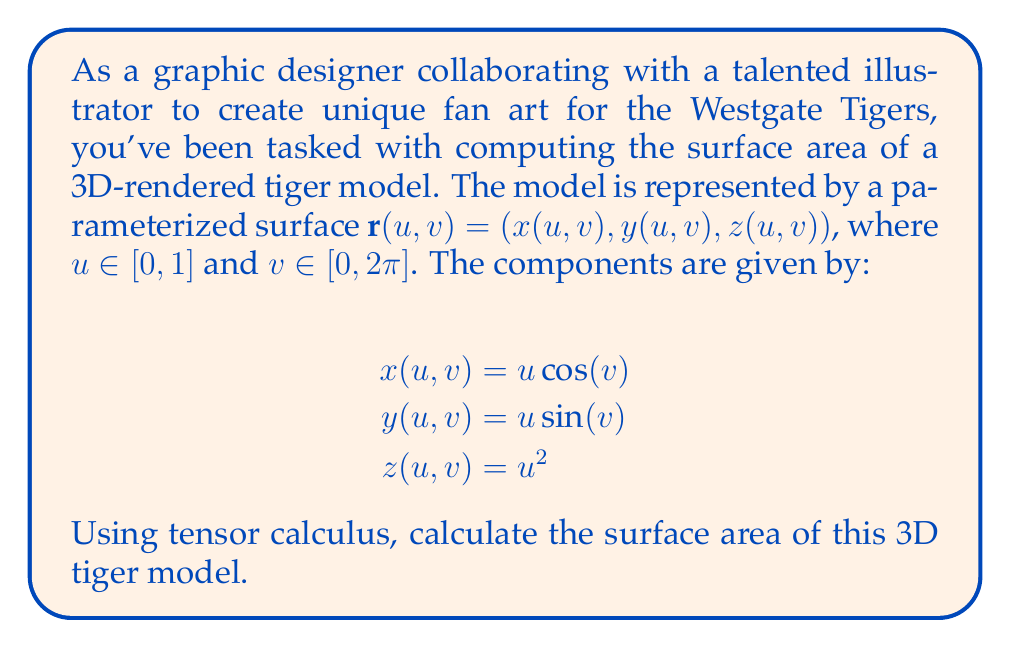What is the answer to this math problem? To compute the surface area using tensor calculus, we'll follow these steps:

1) First, we need to calculate the metric tensor $g_{ij}$. For a surface parameterized by $(u,v)$, the metric tensor is given by:

   $$g_{ij} = \begin{pmatrix}
   \mathbf{r}_u \cdot \mathbf{r}_u & \mathbf{r}_u \cdot \mathbf{r}_v \\
   \mathbf{r}_v \cdot \mathbf{r}_u & \mathbf{r}_v \cdot \mathbf{r}_v
   \end{pmatrix}$$

2) Calculate the partial derivatives:
   $$\mathbf{r}_u = (\cos(v), \sin(v), 2u)$$
   $$\mathbf{r}_v = (-u\sin(v), u\cos(v), 0)$$

3) Compute the components of the metric tensor:
   $$g_{11} = \mathbf{r}_u \cdot \mathbf{r}_u = \cos^2(v) + \sin^2(v) + 4u^2 = 1 + 4u^2$$
   $$g_{12} = g_{21} = \mathbf{r}_u \cdot \mathbf{r}_v = 0$$
   $$g_{22} = \mathbf{r}_v \cdot \mathbf{r}_v = u^2\sin^2(v) + u^2\cos^2(v) = u^2$$

4) The determinant of the metric tensor is:
   $$g = \det(g_{ij}) = (1 + 4u^2)(u^2) - 0^2 = u^2 + 4u^4$$

5) The surface area is given by the double integral:
   $$A = \int_0^{2\pi} \int_0^1 \sqrt{g} \, du \, dv$$

6) Substituting and evaluating:
   $$A = \int_0^{2\pi} \int_0^1 \sqrt{u^2 + 4u^4} \, du \, dv$$
   $$= 2\pi \int_0^1 u\sqrt{1 + 4u^2} \, du$$

7) This integral can be solved using the substitution $w = 1 + 4u^2$:
   $$A = \frac{\pi}{4} \int_1^5 \sqrt{w} \, dw$$
   $$= \frac{\pi}{4} \cdot \frac{2}{3}(5^{3/2} - 1^{3/2})$$
   $$= \frac{\pi}{6}(5\sqrt{5} - 1)$$
Answer: $\frac{\pi}{6}(5\sqrt{5} - 1)$ square units 